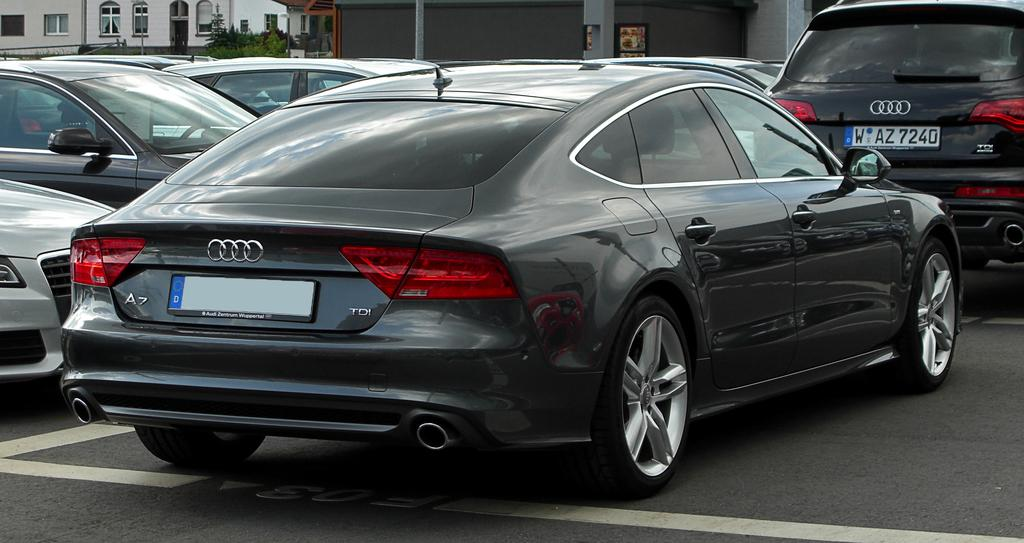<image>
Create a compact narrative representing the image presented. A few Audis parked next to each other the closest one has a blank tag. 